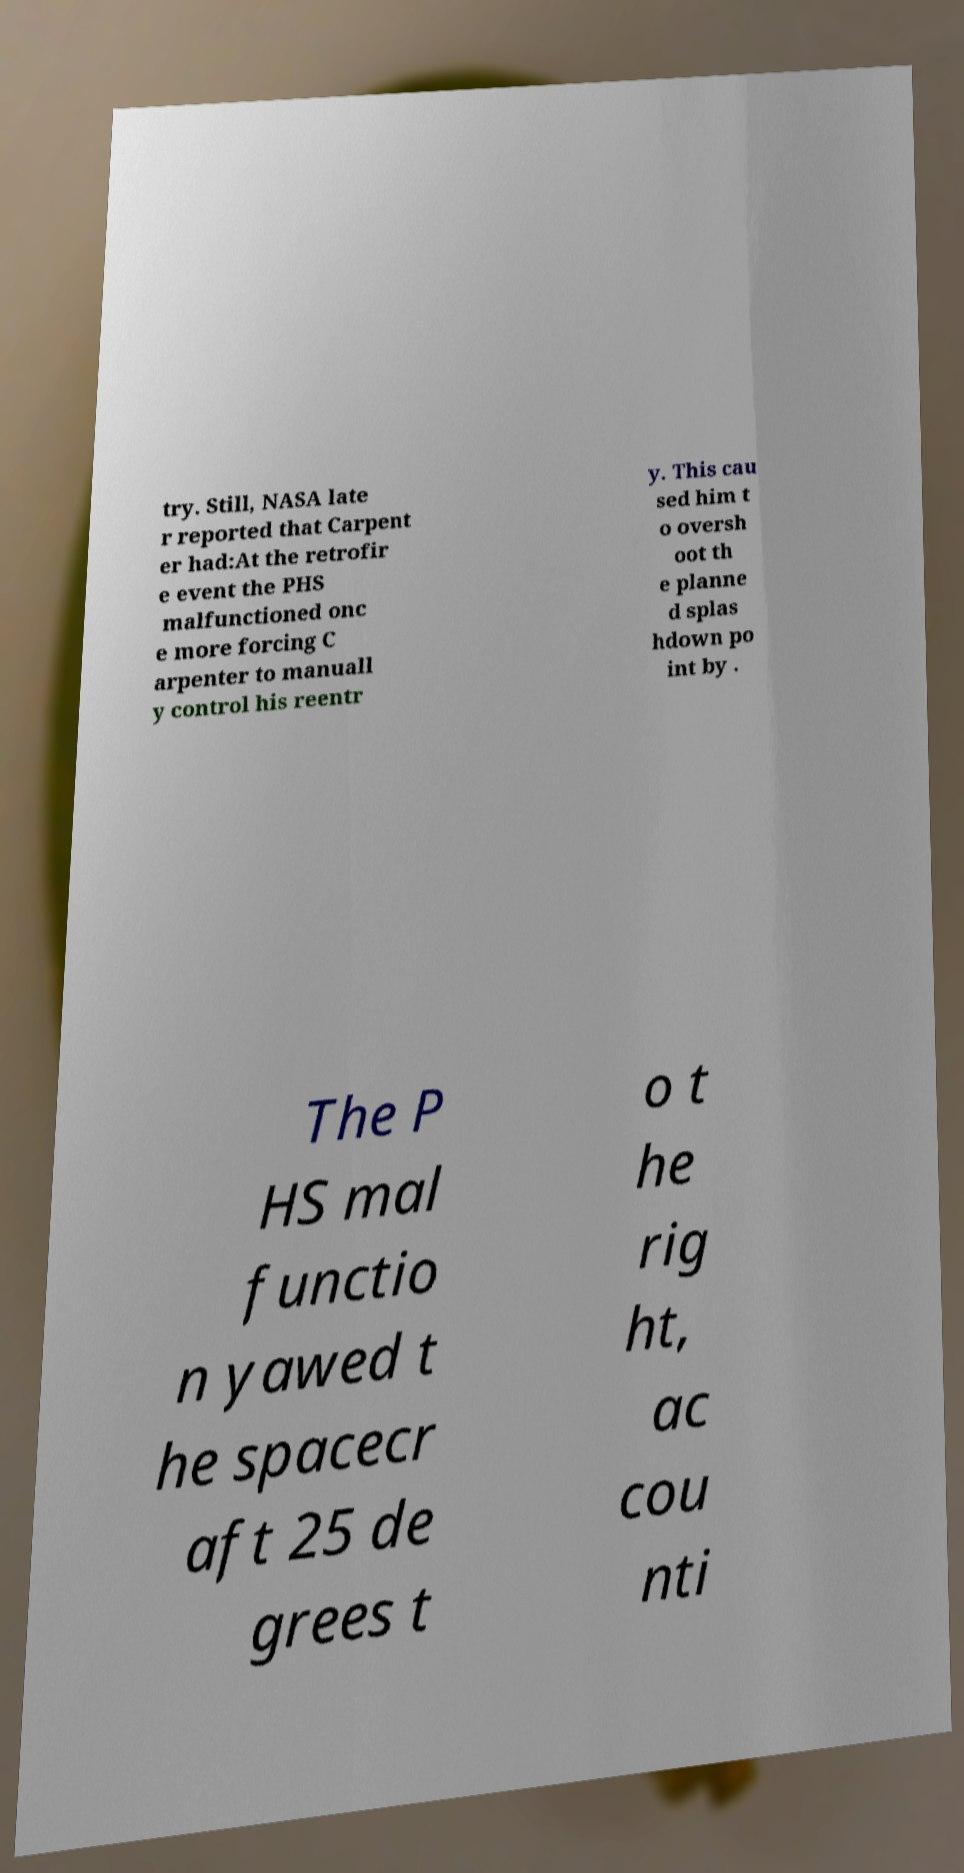There's text embedded in this image that I need extracted. Can you transcribe it verbatim? try. Still, NASA late r reported that Carpent er had:At the retrofir e event the PHS malfunctioned onc e more forcing C arpenter to manuall y control his reentr y. This cau sed him t o oversh oot th e planne d splas hdown po int by . The P HS mal functio n yawed t he spacecr aft 25 de grees t o t he rig ht, ac cou nti 